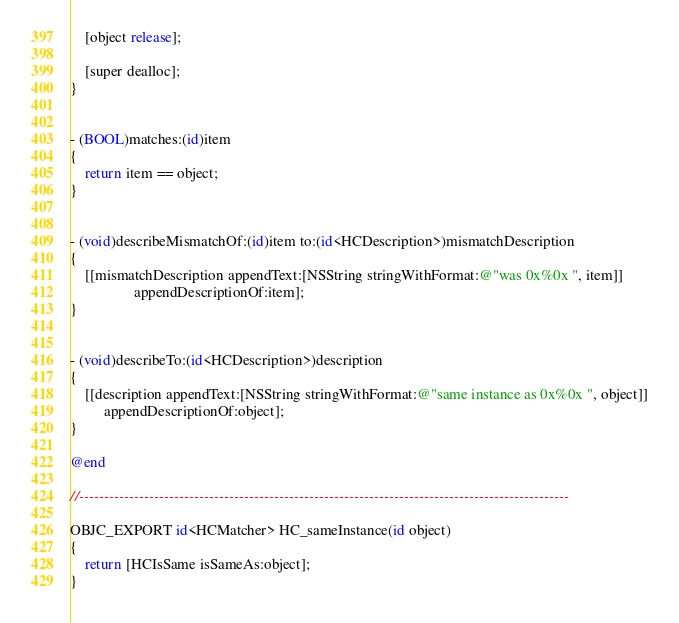<code> <loc_0><loc_0><loc_500><loc_500><_ObjectiveC_>    [object release];
    
    [super dealloc];
}


- (BOOL)matches:(id)item
{
    return item == object;
}


- (void)describeMismatchOf:(id)item to:(id<HCDescription>)mismatchDescription
{
    [[mismatchDescription appendText:[NSString stringWithFormat:@"was 0x%0x ", item]]
                 appendDescriptionOf:item];
}


- (void)describeTo:(id<HCDescription>)description
{
    [[description appendText:[NSString stringWithFormat:@"same instance as 0x%0x ", object]]
         appendDescriptionOf:object];
}

@end

//--------------------------------------------------------------------------------------------------

OBJC_EXPORT id<HCMatcher> HC_sameInstance(id object)
{
    return [HCIsSame isSameAs:object];
}
</code> 